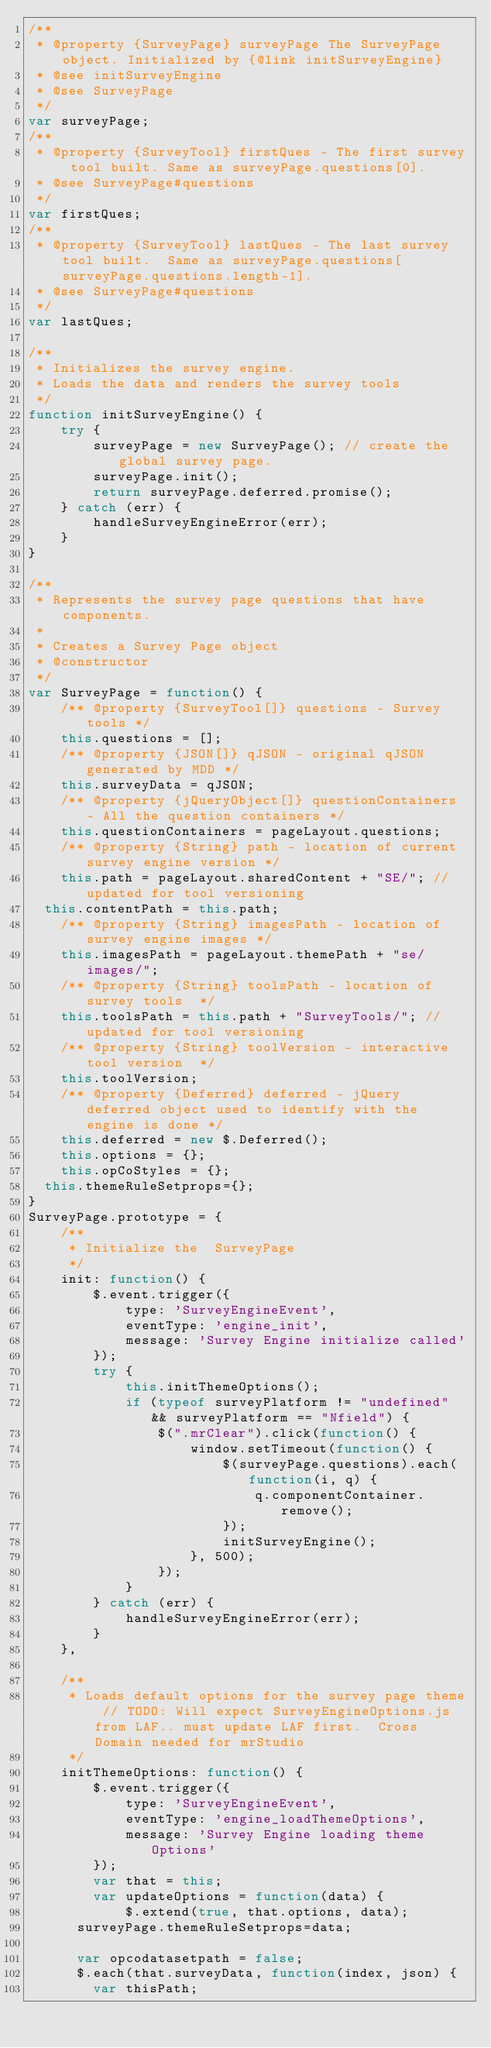Convert code to text. <code><loc_0><loc_0><loc_500><loc_500><_JavaScript_>/**
 * @property {SurveyPage} surveyPage The SurveyPage object. Initialized by {@link initSurveyEngine}
 * @see initSurveyEngine
 * @see SurveyPage
 */
var surveyPage;
/**
 * @property {SurveyTool} firstQues - The first survey tool built. Same as surveyPage.questions[0].
 * @see SurveyPage#questions
 */
var firstQues;
/**
 * @property {SurveyTool} lastQues - The last survey tool built.  Same as surveyPage.questions[surveyPage.questions.length-1].
 * @see SurveyPage#questions
 */
var lastQues;

/**
 * Initializes the survey engine.
 * Loads the data and renders the survey tools
 */
function initSurveyEngine() {
    try {
        surveyPage = new SurveyPage(); // create the global survey page.
        surveyPage.init();
        return surveyPage.deferred.promise();
    } catch (err) {
        handleSurveyEngineError(err);
    }
}

/**
 * Represents the survey page questions that have components.
 *
 * Creates a Survey Page object
 * @constructor
 */
var SurveyPage = function() {
    /** @property {SurveyTool[]} questions - Survey tools */
    this.questions = [];
    /** @property {JSON[]} qJSON - original qJSON generated by MDD */
    this.surveyData = qJSON;
    /** @property {jQueryObject[]} questionContainers - All the question containers */
    this.questionContainers = pageLayout.questions;
    /** @property {String} path - location of current survey engine version */
    this.path = pageLayout.sharedContent + "SE/"; //updated for tool versioning
	this.contentPath = this.path;
    /** @property {String} imagesPath - location of survey engine images */
    this.imagesPath = pageLayout.themePath + "se/images/";
    /** @property {String} toolsPath - location of survey tools  */
    this.toolsPath = this.path + "SurveyTools/"; //updated for tool versioning
    /** @property {String} toolVersion - interactive tool version  */
    this.toolVersion;
    /** @property {Deferred} deferred - jQuery deferred object used to identify with the engine is done */
    this.deferred = new $.Deferred();
    this.options = {};
    this.opCoStyles = {};
	this.themeRuleSetprops={};
}
SurveyPage.prototype = {
    /**
     * Initialize the  SurveyPage
     */
    init: function() {
        $.event.trigger({
            type: 'SurveyEngineEvent',
            eventType: 'engine_init',
            message: 'Survey Engine initialize called'
        });
        try {
            this.initThemeOptions();
            if (typeof surveyPlatform != "undefined" && surveyPlatform == "Nfield") {
                $(".mrClear").click(function() {
                    window.setTimeout(function() {
                        $(surveyPage.questions).each(function(i, q) {
                            q.componentContainer.remove();
                        });
                        initSurveyEngine();
                    }, 500);
                });
            }
        } catch (err) {
            handleSurveyEngineError(err);
        }
    },

    /**
     * Loads default options for the survey page theme // TODO: Will expect SurveyEngineOptions.js from LAF.. must update LAF first.  Cross Domain needed for mrStudio
     */
    initThemeOptions: function() {
        $.event.trigger({
            type: 'SurveyEngineEvent',
            eventType: 'engine_loadThemeOptions',
            message: 'Survey Engine loading theme Options'
        });
        var that = this;
        var updateOptions = function(data) {
            $.extend(true, that.options, data);
			surveyPage.themeRuleSetprops=data;
			
			var opcodatasetpath = false;	
			$.each(that.surveyData, function(index, json) {
				var thisPath;</code> 